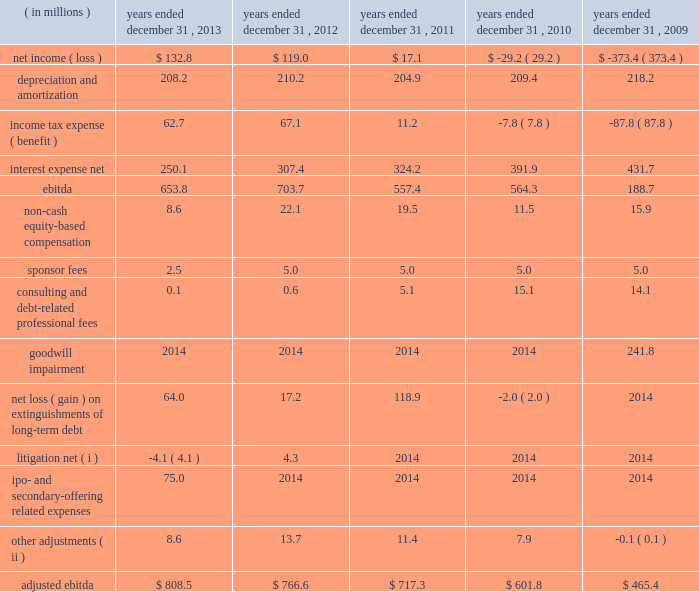( 2 ) for purposes of calculating the ratio of earnings to fixed charges , earnings consist of earnings before income taxes minus income from equity investees plus fixed charges .
Fixed charges consist of interest expense and the portion of rental expense we believe is representative of the interest component of rental expense .
( a ) for the years ended december 31 , 2010 and 2009 , earnings available for fixed charges were inadequate to cover fixed charges by $ 37.0 million and $ 461.2 million , respectively .
( 3 ) ebitda is defined as consolidated net income ( loss ) before interest expense , income tax expense ( benefit ) , depreciation , and amortization .
Adjusted ebitda , which is a measure defined in our credit agreements , is calculated by adjusting ebitda for certain items of income and expense including ( but not limited to ) the following : ( a ) non-cash equity-based compensation ; ( b ) goodwill impairment charges ; ( c ) sponsor fees ; ( d ) certain consulting fees ; ( e ) debt-related legal and accounting costs ; ( f ) equity investment income and losses ; ( g ) certain severance and retention costs ; ( h ) gains and losses from the early extinguishment of debt ; ( i ) gains and losses from asset dispositions outside the ordinary course of business ; and ( j ) non-recurring , extraordinary or unusual gains or losses or expenses .
We have included a reconciliation of ebitda and adjusted ebitda in the table below .
Both ebitda and adjusted ebitda are considered non-gaap financial measures .
Generally , a non-gaap financial measure is a numerical measure of a company 2019s performance , financial position or cash flows that either excludes or includes amounts that are not normally included or excluded in the most directly comparable measure calculated and presented in accordance with gaap .
Non-gaap measures used by the company may differ from similar measures used by other companies , even when similar terms are used to identify such measures .
We believe that ebitda and adjusted ebitda provide helpful information with respect to our operating performance and cash flows including our ability to meet our future debt service , capital expenditures and working capital requirements .
Adjusted ebitda also provides helpful information as it is the primary measure used in certain financial covenants contained in our credit agreements .
The following unaudited table sets forth reconciliations of net income ( loss ) to ebitda and ebitda to adjusted ebitda for the periods presented: .
( i ) relates to unusual , non-recurring litigation matters .
( ii ) includes certain retention costs and equity investment income , certain severance costs in 2009 and a gain related to the sale of the informacast software and equipment in 2009. .
What was the 2012 effective tax rate? 
Computations: (67.1 / (67.1 + 119.0))
Answer: 0.36056. 